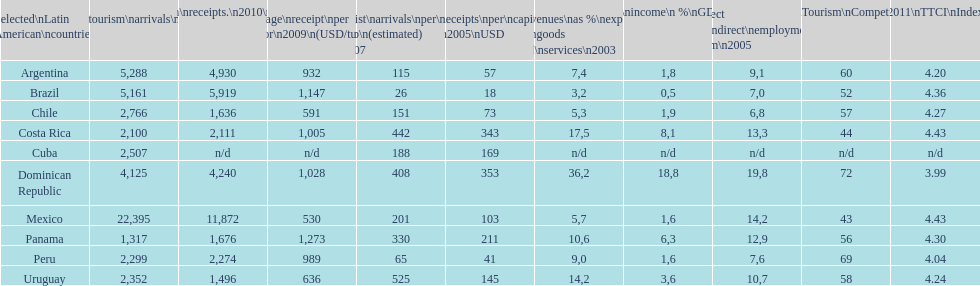What is the last country listed on this chart? Uruguay. 